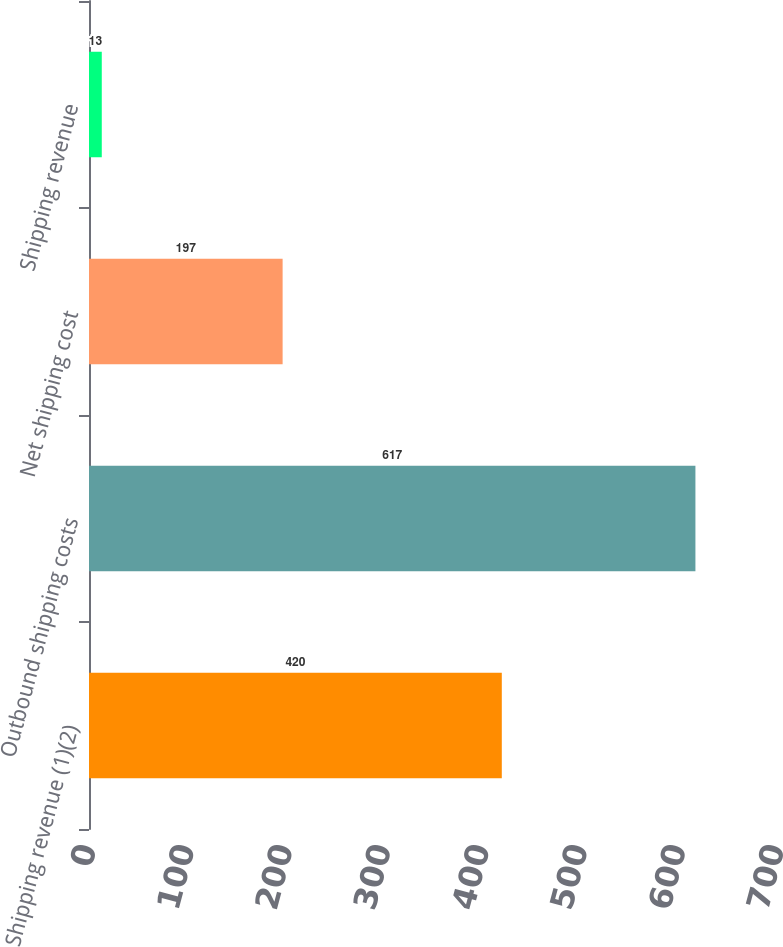Convert chart to OTSL. <chart><loc_0><loc_0><loc_500><loc_500><bar_chart><fcel>Shipping revenue (1)(2)<fcel>Outbound shipping costs<fcel>Net shipping cost<fcel>Shipping revenue<nl><fcel>420<fcel>617<fcel>197<fcel>13<nl></chart> 